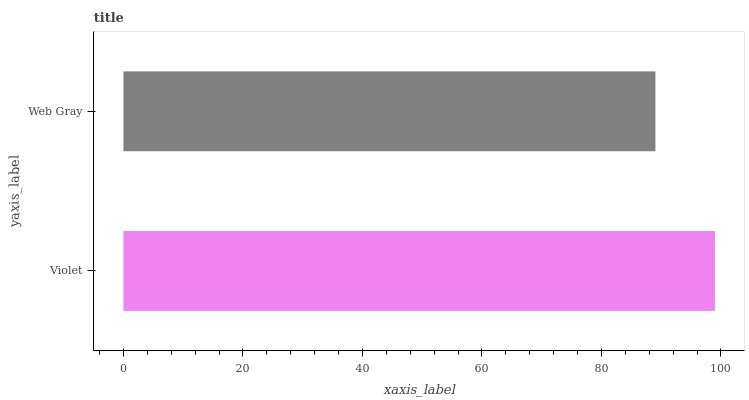Is Web Gray the minimum?
Answer yes or no. Yes. Is Violet the maximum?
Answer yes or no. Yes. Is Web Gray the maximum?
Answer yes or no. No. Is Violet greater than Web Gray?
Answer yes or no. Yes. Is Web Gray less than Violet?
Answer yes or no. Yes. Is Web Gray greater than Violet?
Answer yes or no. No. Is Violet less than Web Gray?
Answer yes or no. No. Is Violet the high median?
Answer yes or no. Yes. Is Web Gray the low median?
Answer yes or no. Yes. Is Web Gray the high median?
Answer yes or no. No. Is Violet the low median?
Answer yes or no. No. 